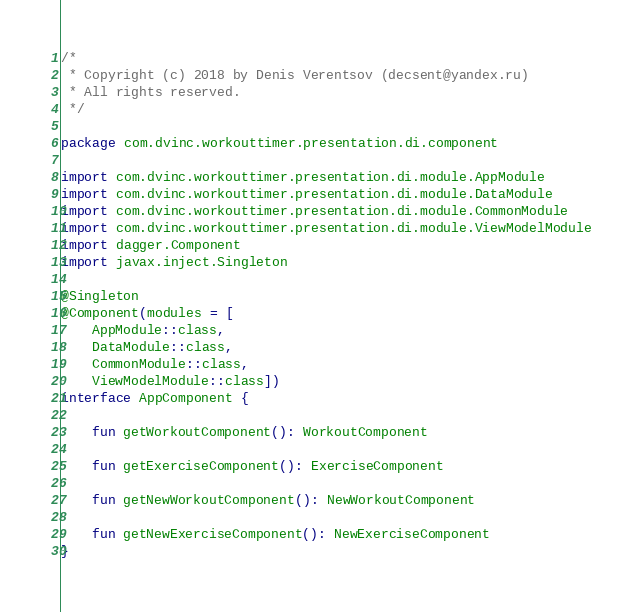Convert code to text. <code><loc_0><loc_0><loc_500><loc_500><_Kotlin_>/*
 * Copyright (c) 2018 by Denis Verentsov (decsent@yandex.ru)
 * All rights reserved.
 */

package com.dvinc.workouttimer.presentation.di.component

import com.dvinc.workouttimer.presentation.di.module.AppModule
import com.dvinc.workouttimer.presentation.di.module.DataModule
import com.dvinc.workouttimer.presentation.di.module.CommonModule
import com.dvinc.workouttimer.presentation.di.module.ViewModelModule
import dagger.Component
import javax.inject.Singleton

@Singleton
@Component(modules = [
    AppModule::class,
    DataModule::class,
    CommonModule::class,
    ViewModelModule::class])
interface AppComponent {

    fun getWorkoutComponent(): WorkoutComponent

    fun getExerciseComponent(): ExerciseComponent

    fun getNewWorkoutComponent(): NewWorkoutComponent

    fun getNewExerciseComponent(): NewExerciseComponent
}
</code> 